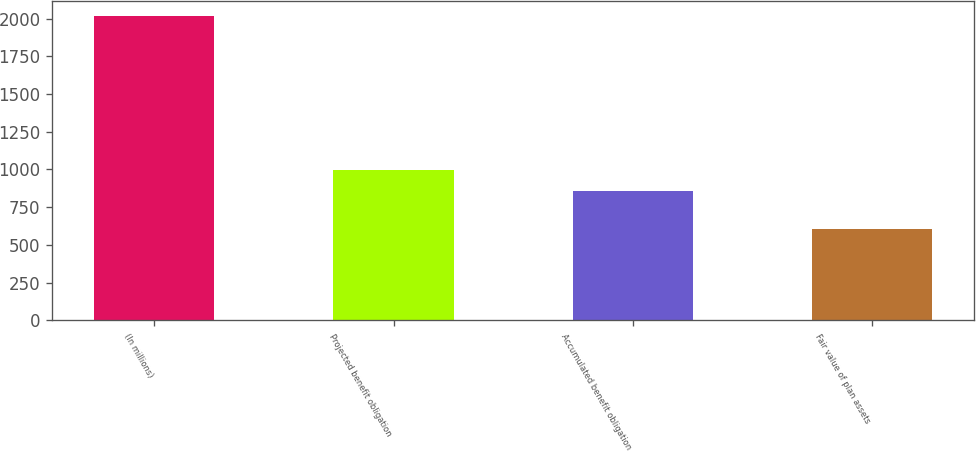Convert chart. <chart><loc_0><loc_0><loc_500><loc_500><bar_chart><fcel>(In millions)<fcel>Projected benefit obligation<fcel>Accumulated benefit obligation<fcel>Fair value of plan assets<nl><fcel>2016<fcel>995.9<fcel>855<fcel>607<nl></chart> 